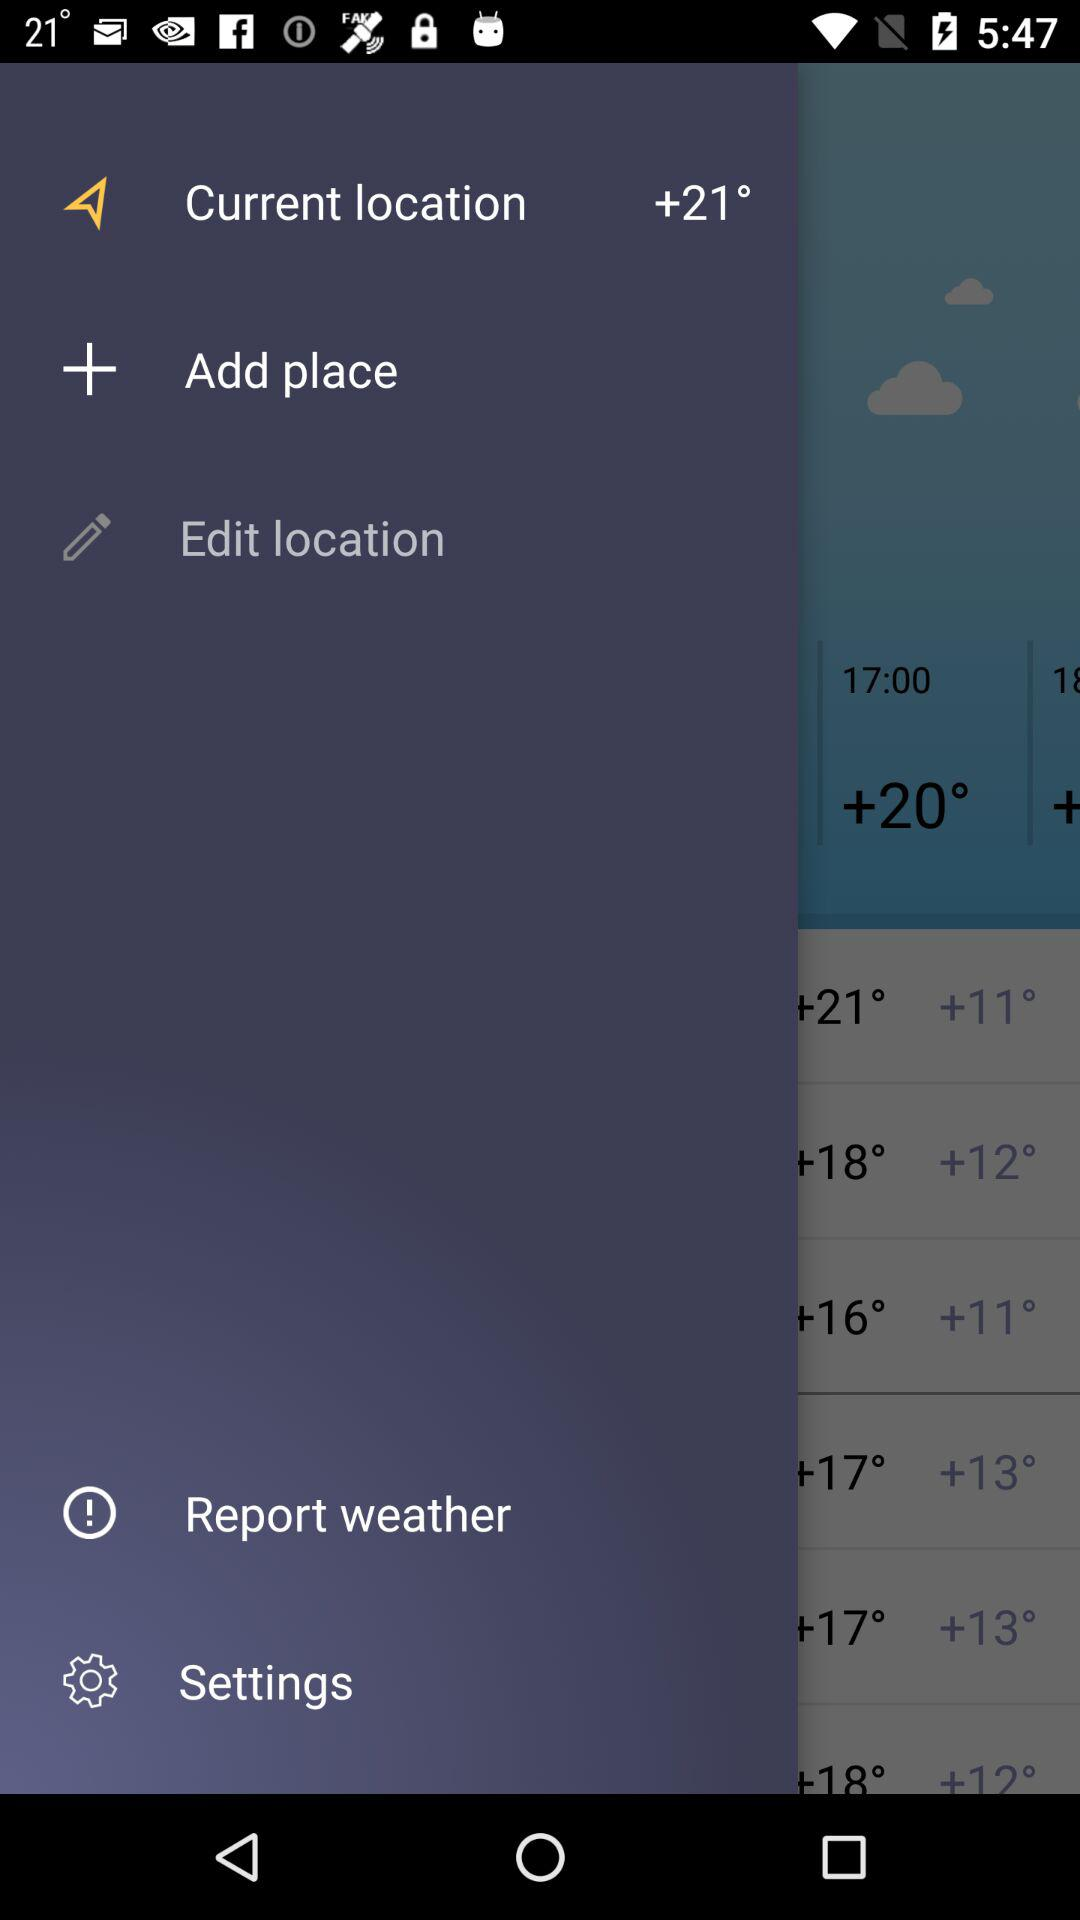How much warmer is the temperature of the location with the +20° text than the location with the +16° text?
Answer the question using a single word or phrase. 4 